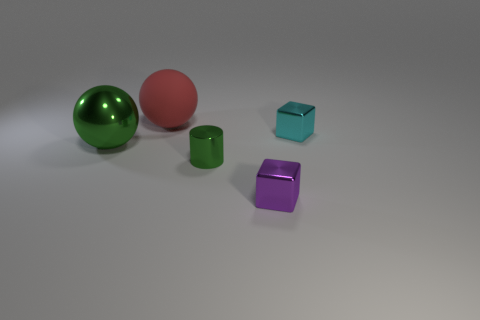There is a cylinder that is the same color as the metallic sphere; what material is it?
Offer a very short reply. Metal. The purple object that is the same size as the cyan metal thing is what shape?
Your answer should be compact. Cube. How many other objects are there of the same color as the shiny ball?
Provide a succinct answer. 1. What is the size of the ball that is behind the cube on the right side of the tiny purple object?
Ensure brevity in your answer.  Large. Are the big sphere in front of the cyan thing and the cylinder made of the same material?
Provide a short and direct response. Yes. What shape is the big thing behind the cyan block?
Offer a very short reply. Sphere. What number of purple metal things have the same size as the green metal cylinder?
Ensure brevity in your answer.  1. What size is the metallic ball?
Make the answer very short. Large. How many tiny purple things are left of the cyan cube?
Give a very brief answer. 1. There is a purple object that is the same material as the tiny cyan thing; what shape is it?
Keep it short and to the point. Cube. 